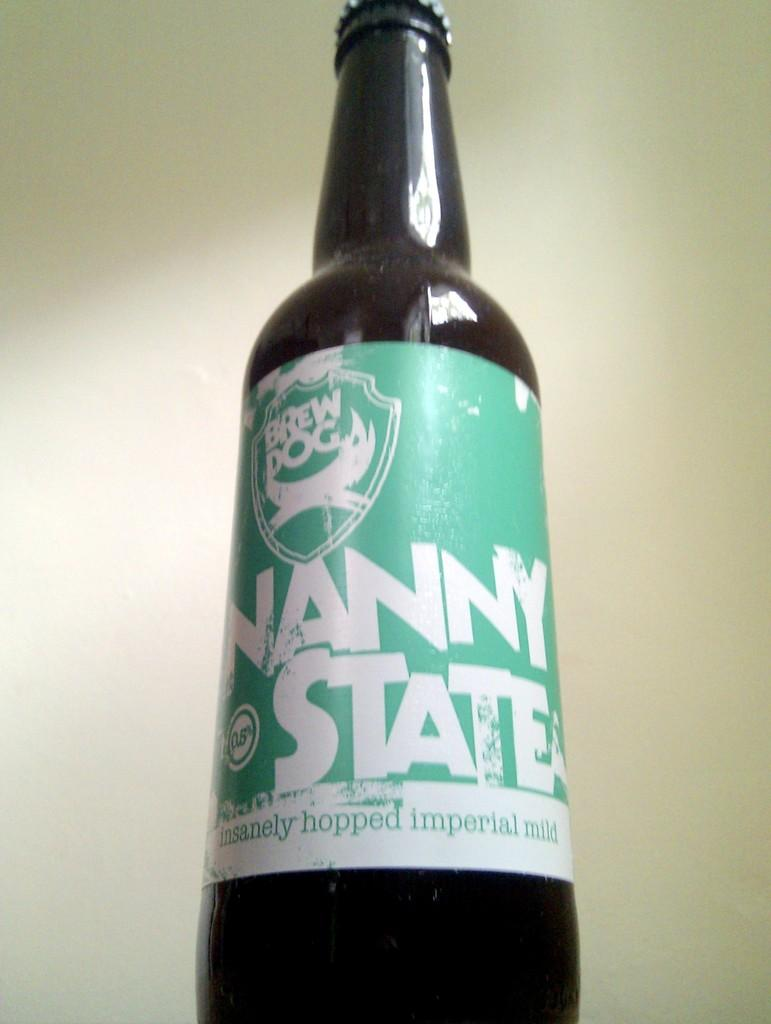<image>
Provide a brief description of the given image. A bottle of Brew Dog Nanny State imperial mild beer. 